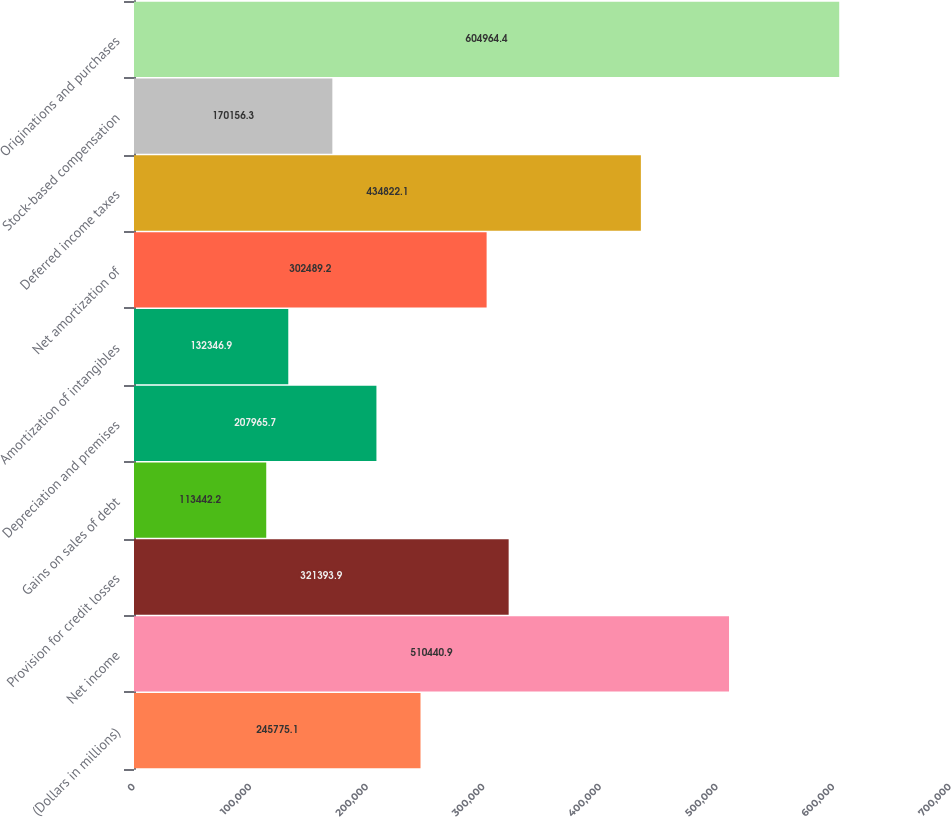<chart> <loc_0><loc_0><loc_500><loc_500><bar_chart><fcel>(Dollars in millions)<fcel>Net income<fcel>Provision for credit losses<fcel>Gains on sales of debt<fcel>Depreciation and premises<fcel>Amortization of intangibles<fcel>Net amortization of<fcel>Deferred income taxes<fcel>Stock-based compensation<fcel>Originations and purchases<nl><fcel>245775<fcel>510441<fcel>321394<fcel>113442<fcel>207966<fcel>132347<fcel>302489<fcel>434822<fcel>170156<fcel>604964<nl></chart> 